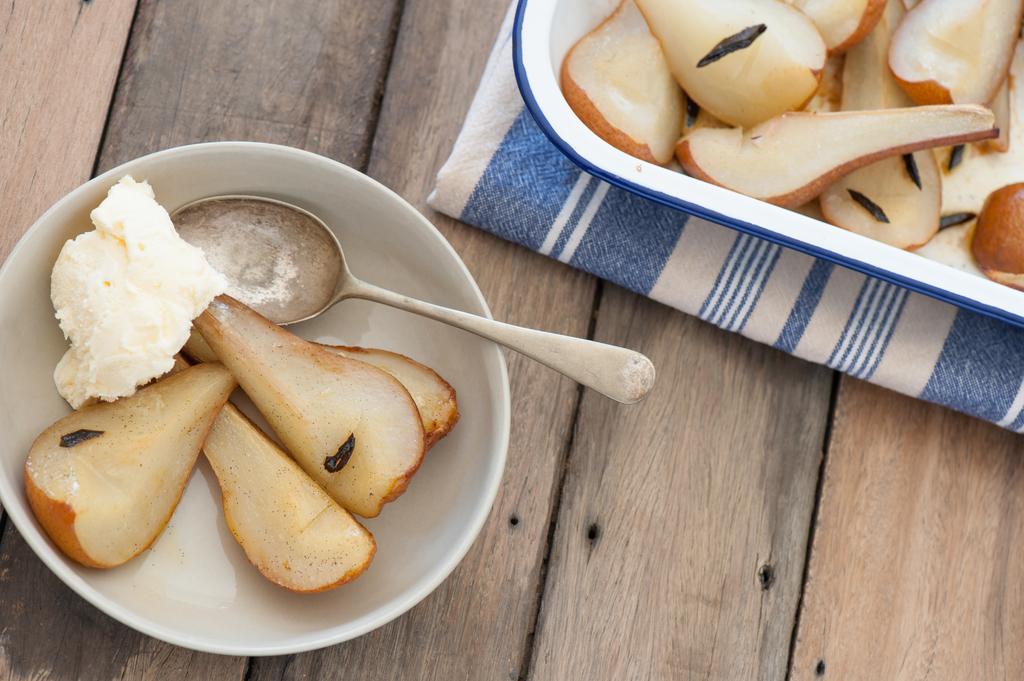How would you summarize this image in a sentence or two? Here on the platform there are food items in a plate on a cloth and there are food items and a spoon in a bowl. 